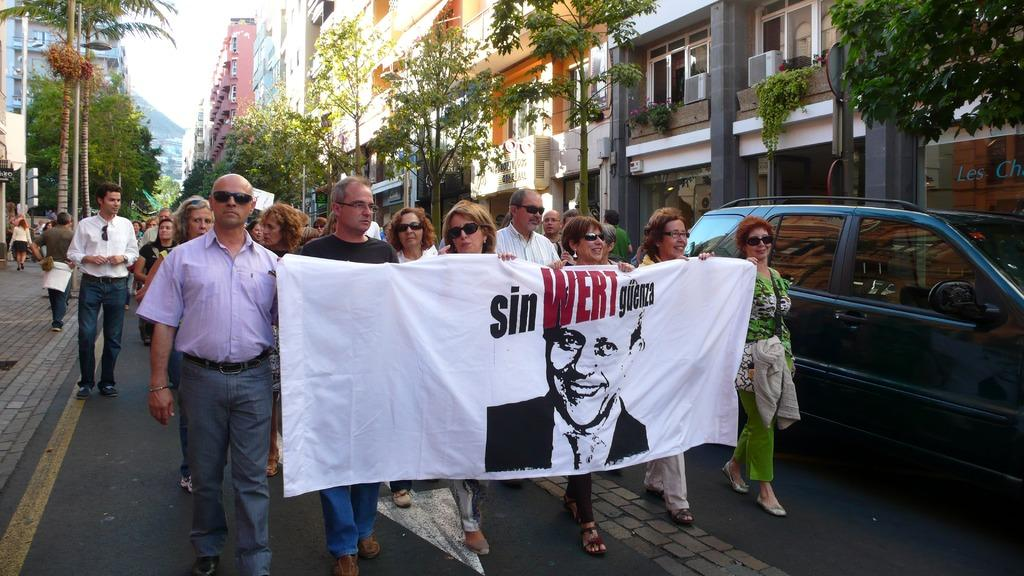What are the people in the image doing? The people in the image are walking. What are the people holding while walking? The people are holding a banner. What can be seen on the road in the image? There is a car on the road in the image. What is visible in the background of the image? Buildings, trees, and the sky are visible in the background of the image}. What type of wool can be seen in the image? There is no wool present in the image. What time of day is it in the image, considering it's an afternoon? The time of day cannot be determined from the image alone, as there is no indication of the time. 